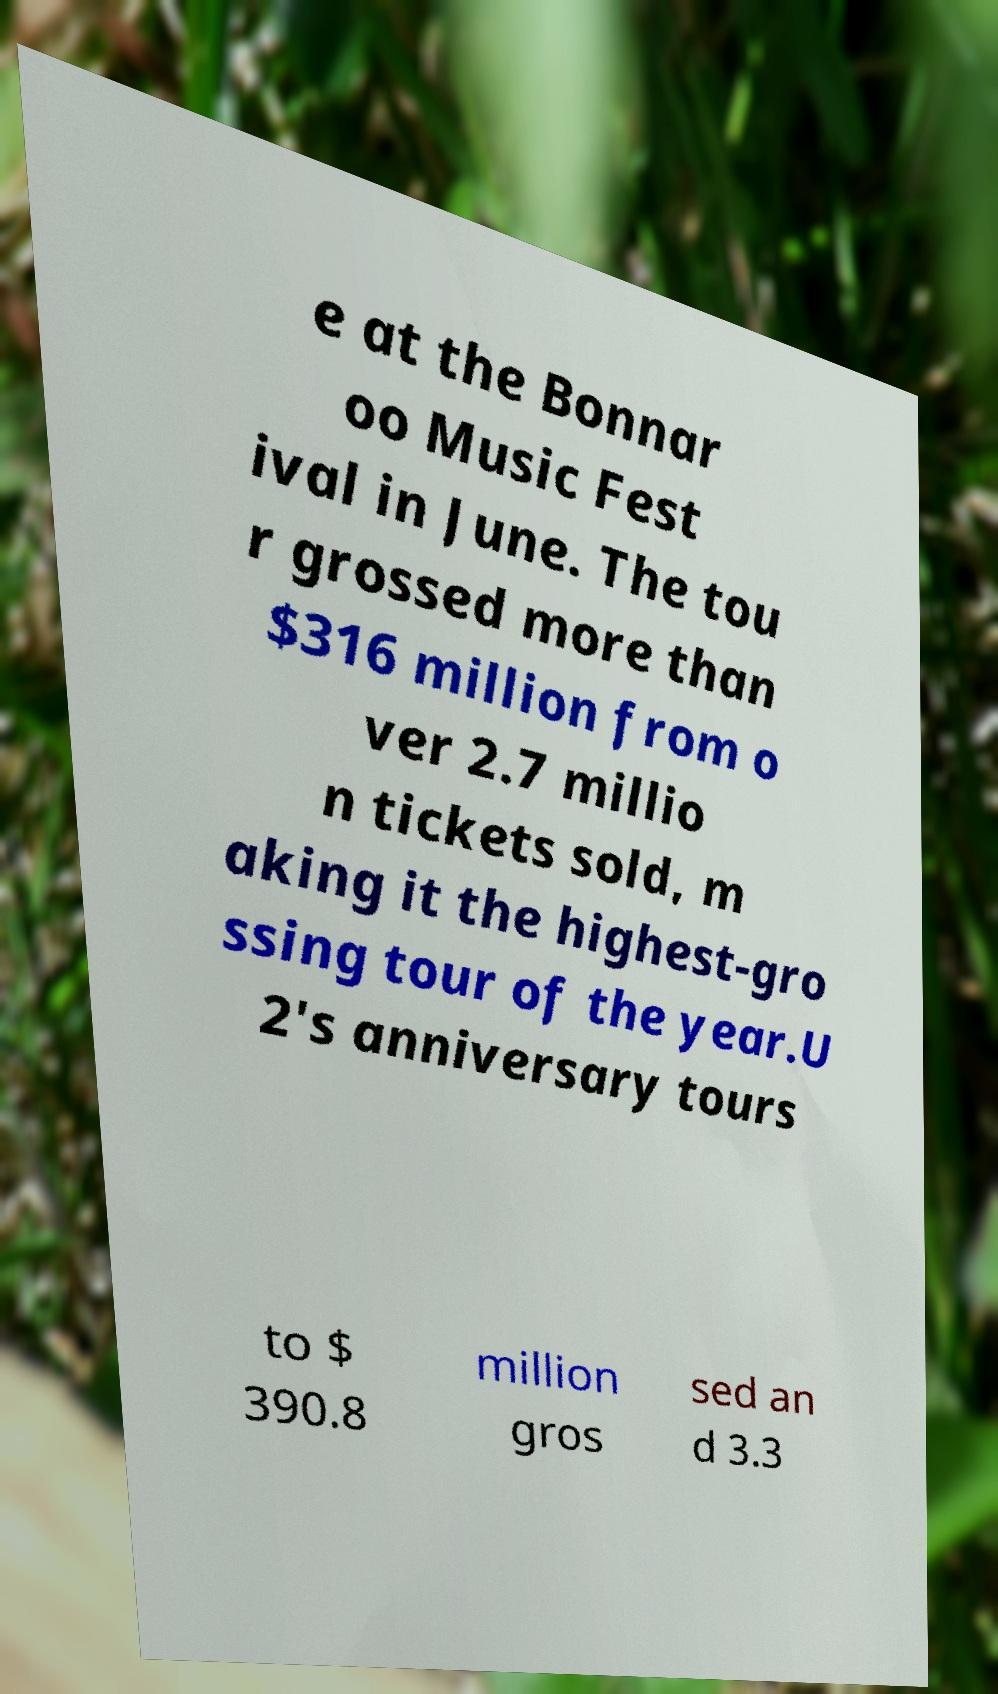I need the written content from this picture converted into text. Can you do that? e at the Bonnar oo Music Fest ival in June. The tou r grossed more than $316 million from o ver 2.7 millio n tickets sold, m aking it the highest-gro ssing tour of the year.U 2's anniversary tours to $ 390.8 million gros sed an d 3.3 